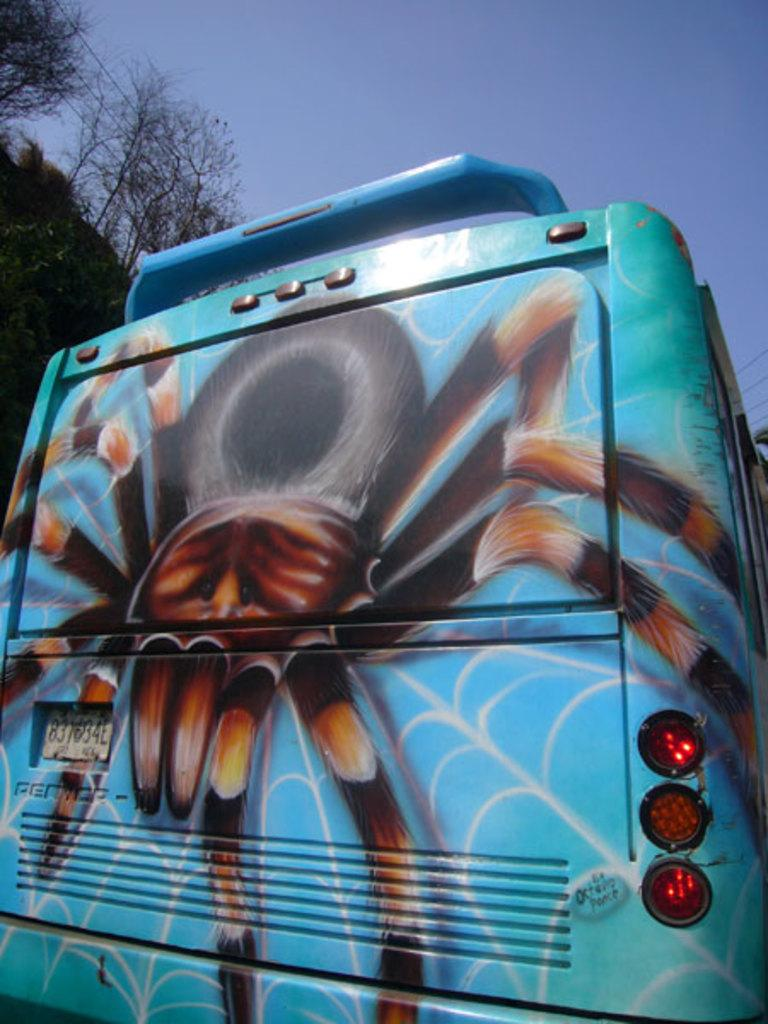What type of vehicle is in the image? There is a vehicle in the image, but it is truncated, so we cannot identify the exact type. What features can be seen on the vehicle? The vehicle has lights and a number plate. Additionally, there is a picture of a spider on the vehicle. What can be seen in the background of the image? There are trees and the sky visible in the background of the image. What type of umbrella is being used to shield the vehicle from the rain in the image? There is no umbrella present in the image, and it is not raining. How many arrows are visible in the quiver attached to the vehicle in the image? There is no quiver or arrows present in the image. 